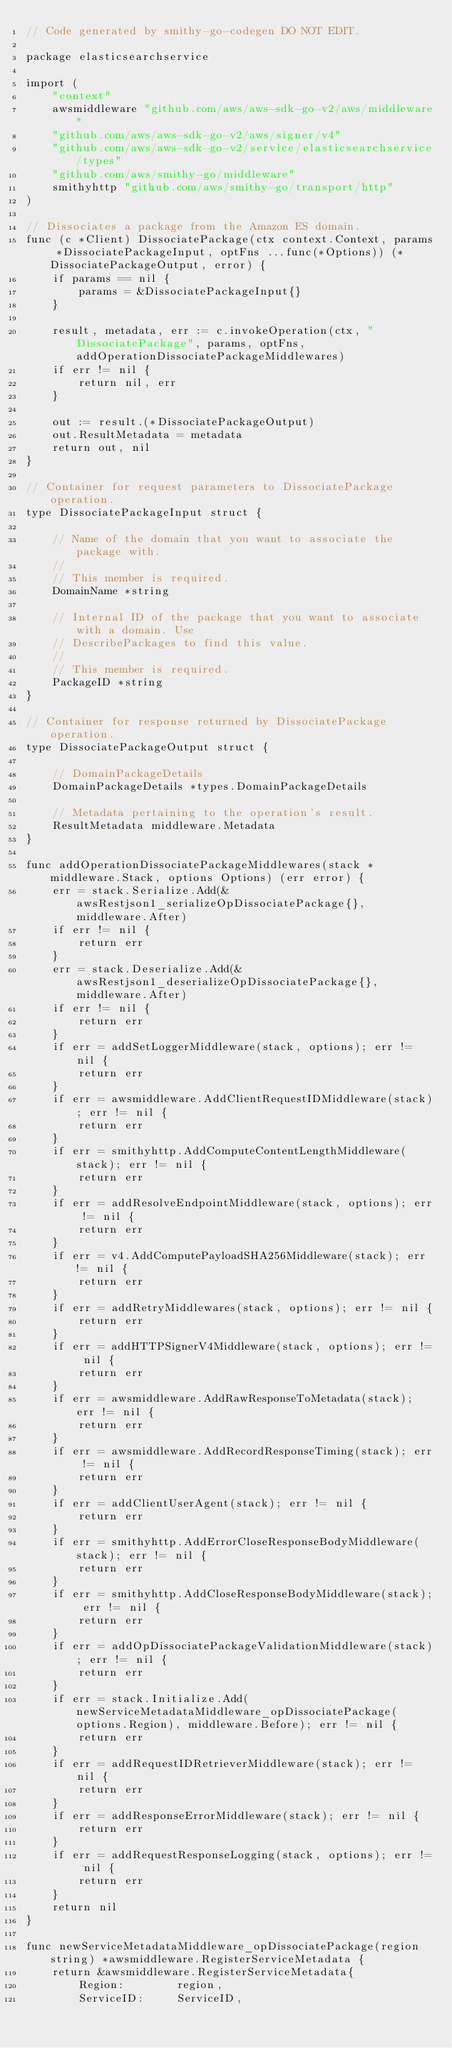<code> <loc_0><loc_0><loc_500><loc_500><_Go_>// Code generated by smithy-go-codegen DO NOT EDIT.

package elasticsearchservice

import (
	"context"
	awsmiddleware "github.com/aws/aws-sdk-go-v2/aws/middleware"
	"github.com/aws/aws-sdk-go-v2/aws/signer/v4"
	"github.com/aws/aws-sdk-go-v2/service/elasticsearchservice/types"
	"github.com/aws/smithy-go/middleware"
	smithyhttp "github.com/aws/smithy-go/transport/http"
)

// Dissociates a package from the Amazon ES domain.
func (c *Client) DissociatePackage(ctx context.Context, params *DissociatePackageInput, optFns ...func(*Options)) (*DissociatePackageOutput, error) {
	if params == nil {
		params = &DissociatePackageInput{}
	}

	result, metadata, err := c.invokeOperation(ctx, "DissociatePackage", params, optFns, addOperationDissociatePackageMiddlewares)
	if err != nil {
		return nil, err
	}

	out := result.(*DissociatePackageOutput)
	out.ResultMetadata = metadata
	return out, nil
}

// Container for request parameters to DissociatePackage operation.
type DissociatePackageInput struct {

	// Name of the domain that you want to associate the package with.
	//
	// This member is required.
	DomainName *string

	// Internal ID of the package that you want to associate with a domain. Use
	// DescribePackages to find this value.
	//
	// This member is required.
	PackageID *string
}

// Container for response returned by DissociatePackage operation.
type DissociatePackageOutput struct {

	// DomainPackageDetails
	DomainPackageDetails *types.DomainPackageDetails

	// Metadata pertaining to the operation's result.
	ResultMetadata middleware.Metadata
}

func addOperationDissociatePackageMiddlewares(stack *middleware.Stack, options Options) (err error) {
	err = stack.Serialize.Add(&awsRestjson1_serializeOpDissociatePackage{}, middleware.After)
	if err != nil {
		return err
	}
	err = stack.Deserialize.Add(&awsRestjson1_deserializeOpDissociatePackage{}, middleware.After)
	if err != nil {
		return err
	}
	if err = addSetLoggerMiddleware(stack, options); err != nil {
		return err
	}
	if err = awsmiddleware.AddClientRequestIDMiddleware(stack); err != nil {
		return err
	}
	if err = smithyhttp.AddComputeContentLengthMiddleware(stack); err != nil {
		return err
	}
	if err = addResolveEndpointMiddleware(stack, options); err != nil {
		return err
	}
	if err = v4.AddComputePayloadSHA256Middleware(stack); err != nil {
		return err
	}
	if err = addRetryMiddlewares(stack, options); err != nil {
		return err
	}
	if err = addHTTPSignerV4Middleware(stack, options); err != nil {
		return err
	}
	if err = awsmiddleware.AddRawResponseToMetadata(stack); err != nil {
		return err
	}
	if err = awsmiddleware.AddRecordResponseTiming(stack); err != nil {
		return err
	}
	if err = addClientUserAgent(stack); err != nil {
		return err
	}
	if err = smithyhttp.AddErrorCloseResponseBodyMiddleware(stack); err != nil {
		return err
	}
	if err = smithyhttp.AddCloseResponseBodyMiddleware(stack); err != nil {
		return err
	}
	if err = addOpDissociatePackageValidationMiddleware(stack); err != nil {
		return err
	}
	if err = stack.Initialize.Add(newServiceMetadataMiddleware_opDissociatePackage(options.Region), middleware.Before); err != nil {
		return err
	}
	if err = addRequestIDRetrieverMiddleware(stack); err != nil {
		return err
	}
	if err = addResponseErrorMiddleware(stack); err != nil {
		return err
	}
	if err = addRequestResponseLogging(stack, options); err != nil {
		return err
	}
	return nil
}

func newServiceMetadataMiddleware_opDissociatePackage(region string) *awsmiddleware.RegisterServiceMetadata {
	return &awsmiddleware.RegisterServiceMetadata{
		Region:        region,
		ServiceID:     ServiceID,</code> 